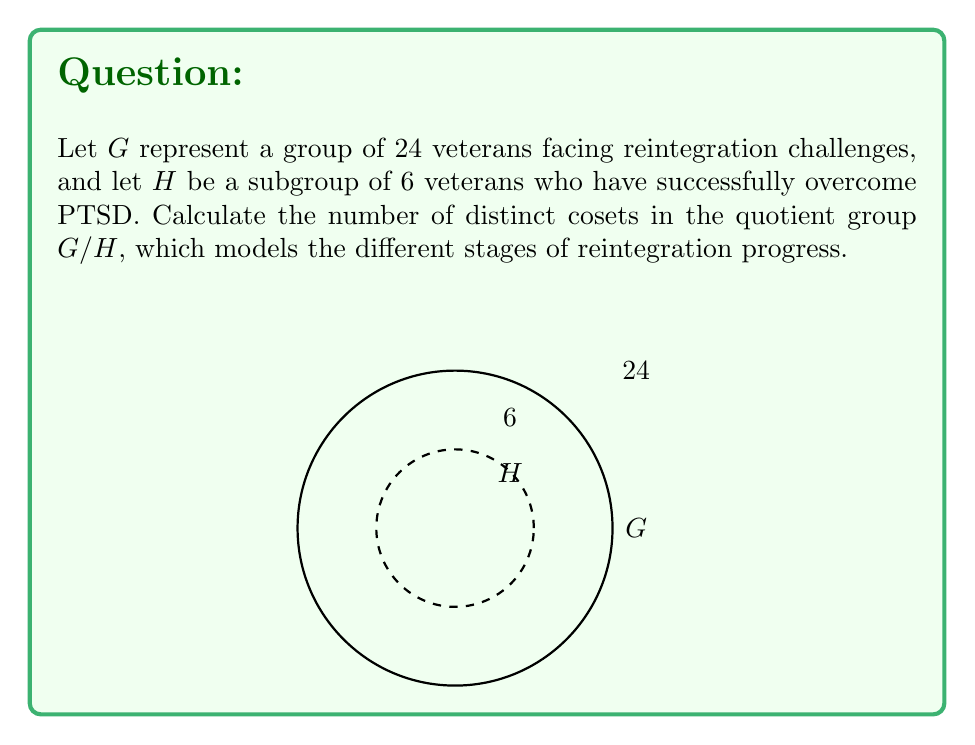Provide a solution to this math problem. To solve this problem, we'll follow these steps:

1) Recall the Lagrange's Theorem, which states that for a finite group $G$ and a subgroup $H$, the order of $G$ is equal to the order of $H$ multiplied by the index of $H$ in $G$. Mathematically:

   $$|G| = |H| \cdot [G:H]$$

2) The index $[G:H]$ is equal to the number of distinct cosets of $H$ in $G$, which is what we're looking for.

3) We're given:
   $|G| = 24$ (total number of veterans)
   $|H| = 6$ (veterans who have overcome PTSD)

4) Let's substitute these values into Lagrange's Theorem:

   $$24 = 6 \cdot [G:H]$$

5) Solve for $[G:H]$:

   $$[G:H] = 24 \div 6 = 4$$

6) Therefore, there are 4 distinct cosets in the quotient group $G/H$.

This result models 4 different stages or groups in the reintegration process, representing the progress veterans make in overcoming challenges similar to PTSD.
Answer: 4 